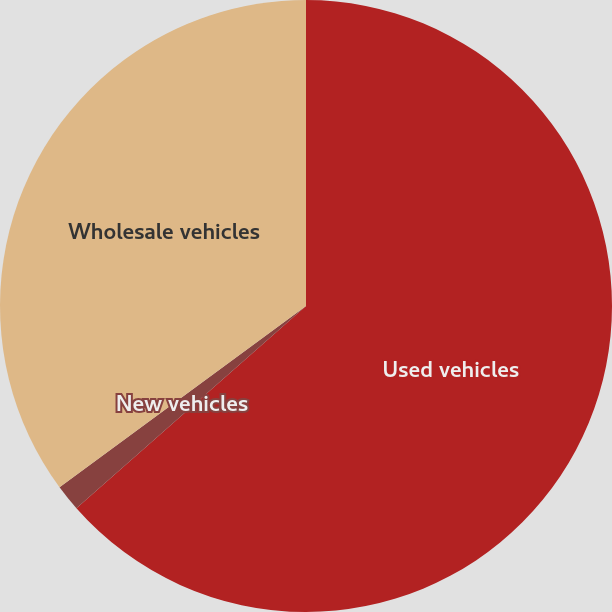Convert chart to OTSL. <chart><loc_0><loc_0><loc_500><loc_500><pie_chart><fcel>Used vehicles<fcel>New vehicles<fcel>Wholesale vehicles<nl><fcel>63.51%<fcel>1.4%<fcel>35.1%<nl></chart> 